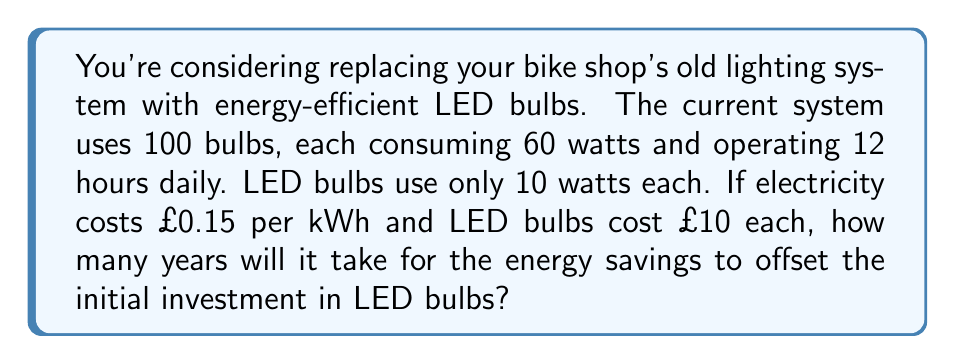Give your solution to this math problem. Let's approach this step-by-step:

1) Calculate current daily energy consumption:
   $$100 \text{ bulbs} \times 60 \text{ watts} \times 12 \text{ hours} = 72,000 \text{ watt-hours} = 72 \text{ kWh}$$

2) Calculate daily energy consumption with LED bulbs:
   $$100 \text{ bulbs} \times 10 \text{ watts} \times 12 \text{ hours} = 12,000 \text{ watt-hours} = 12 \text{ kWh}$$

3) Calculate daily energy savings:
   $$72 \text{ kWh} - 12 \text{ kWh} = 60 \text{ kWh}$$

4) Calculate daily cost savings:
   $$60 \text{ kWh} \times £0.15/\text{kWh} = £9$$

5) Calculate annual cost savings:
   $$£9 \times 365 \text{ days} = £3,285$$

6) Calculate initial investment for LED bulbs:
   $$100 \text{ bulbs} \times £10/\text{bulb} = £1,000$$

7) Calculate time to offset investment:
   $$\text{Time} = \frac{\text{Investment}}{\text{Annual Savings}} = \frac{£1,000}{£3,285/\text{year}} \approx 0.3044 \text{ years}$$

8) Convert to days:
   $$0.3044 \text{ years} \times 365 \text{ days/year} \approx 111 \text{ days}$$
Answer: 111 days 